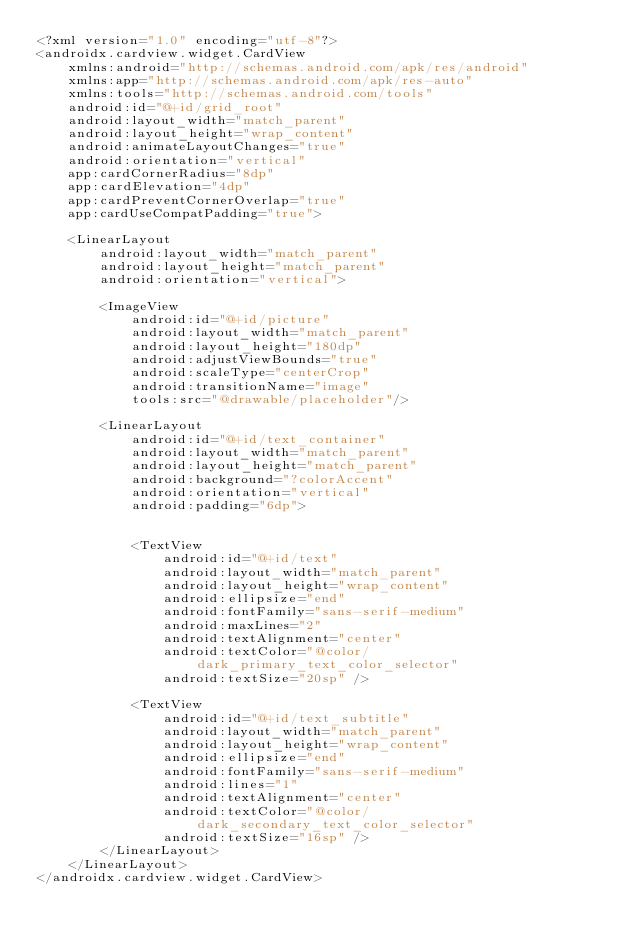Convert code to text. <code><loc_0><loc_0><loc_500><loc_500><_XML_><?xml version="1.0" encoding="utf-8"?>
<androidx.cardview.widget.CardView
    xmlns:android="http://schemas.android.com/apk/res/android"
    xmlns:app="http://schemas.android.com/apk/res-auto"
    xmlns:tools="http://schemas.android.com/tools"
    android:id="@+id/grid_root"
    android:layout_width="match_parent"
    android:layout_height="wrap_content"
    android:animateLayoutChanges="true"
    android:orientation="vertical"
    app:cardCornerRadius="8dp"
    app:cardElevation="4dp"
    app:cardPreventCornerOverlap="true"
    app:cardUseCompatPadding="true">

    <LinearLayout
        android:layout_width="match_parent"
        android:layout_height="match_parent"
        android:orientation="vertical">

        <ImageView
            android:id="@+id/picture"
            android:layout_width="match_parent"
            android:layout_height="180dp"
            android:adjustViewBounds="true"
            android:scaleType="centerCrop"
            android:transitionName="image"
            tools:src="@drawable/placeholder"/>

        <LinearLayout
            android:id="@+id/text_container"
            android:layout_width="match_parent"
            android:layout_height="match_parent"
            android:background="?colorAccent"
            android:orientation="vertical"
            android:padding="6dp">


            <TextView
                android:id="@+id/text"
                android:layout_width="match_parent"
                android:layout_height="wrap_content"
                android:ellipsize="end"
                android:fontFamily="sans-serif-medium"
                android:maxLines="2"
                android:textAlignment="center"
                android:textColor="@color/dark_primary_text_color_selector"
                android:textSize="20sp" />

            <TextView
                android:id="@+id/text_subtitle"
                android:layout_width="match_parent"
                android:layout_height="wrap_content"
                android:ellipsize="end"
                android:fontFamily="sans-serif-medium"
                android:lines="1"
                android:textAlignment="center"
                android:textColor="@color/dark_secondary_text_color_selector"
                android:textSize="16sp" />
        </LinearLayout>
    </LinearLayout>
</androidx.cardview.widget.CardView>
</code> 